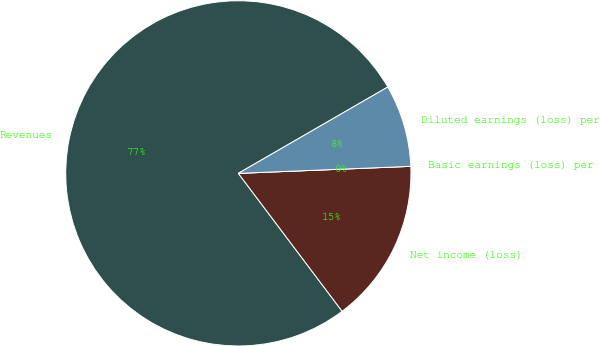Convert chart. <chart><loc_0><loc_0><loc_500><loc_500><pie_chart><fcel>Revenues<fcel>Net income (loss)<fcel>Basic earnings (loss) per<fcel>Diluted earnings (loss) per<nl><fcel>76.92%<fcel>15.38%<fcel>0.0%<fcel>7.69%<nl></chart> 